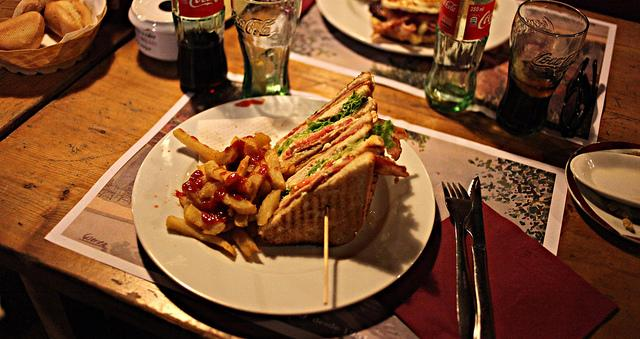What is the name of this sandwich? club 